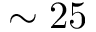<formula> <loc_0><loc_0><loc_500><loc_500>\sim 2 5</formula> 